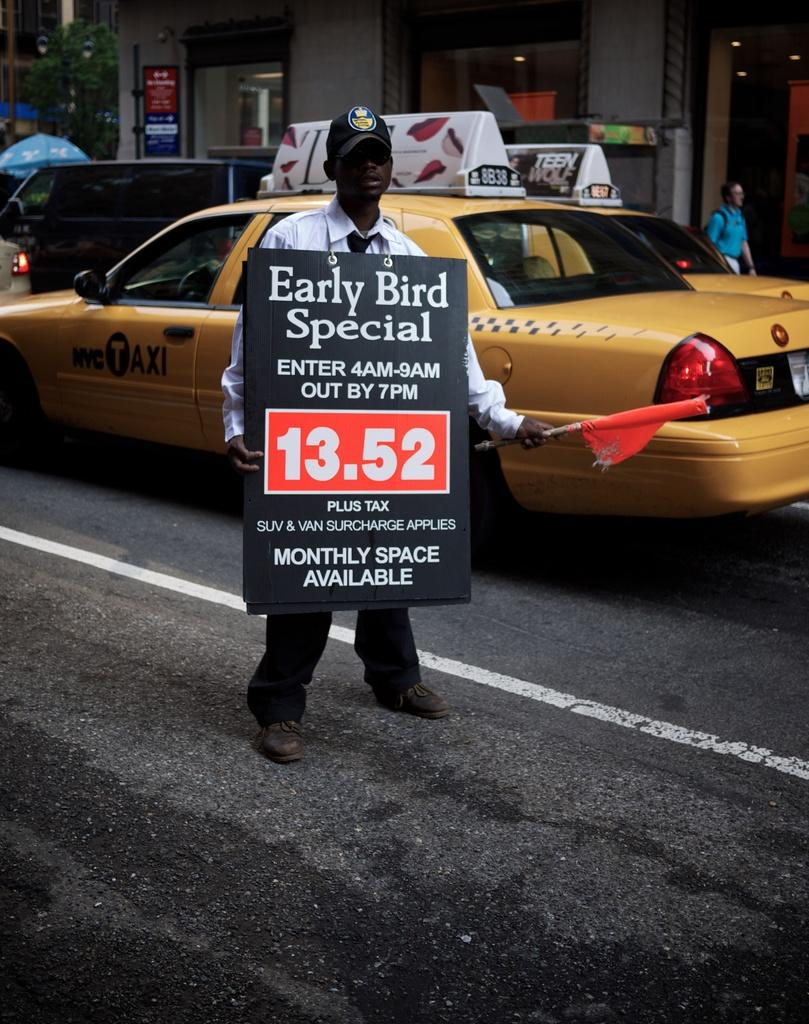<image>
Write a terse but informative summary of the picture. A man with a sandwich board around his neck that says Early Bird Special. 